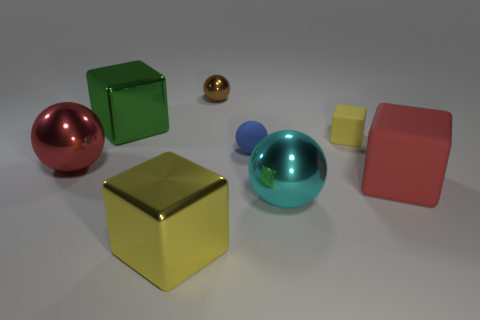Subtract 1 balls. How many balls are left? 3 Subtract all blue balls. Subtract all yellow cubes. How many balls are left? 3 Add 2 big green metal cubes. How many objects exist? 10 Subtract 1 red spheres. How many objects are left? 7 Subtract all small matte objects. Subtract all green metallic objects. How many objects are left? 5 Add 5 green cubes. How many green cubes are left? 6 Add 3 small blue rubber spheres. How many small blue rubber spheres exist? 4 